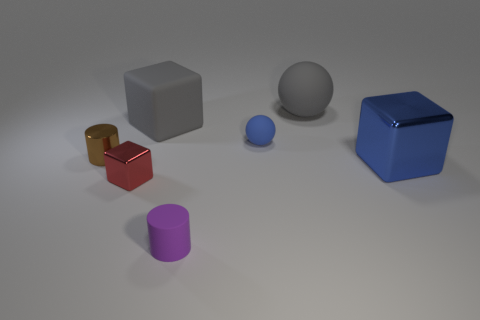How many objects are tiny red objects or rubber cylinders?
Give a very brief answer. 2. There is a red object that is in front of the gray matte thing to the right of the tiny matte thing in front of the red block; what is its size?
Offer a very short reply. Small. What number of spheres have the same color as the large matte cube?
Make the answer very short. 1. What number of red things are the same material as the gray cube?
Provide a short and direct response. 0. How many things are either purple cylinders or matte spheres that are in front of the gray block?
Your response must be concise. 2. What is the color of the sphere in front of the big object behind the gray matte thing on the left side of the big gray ball?
Your answer should be very brief. Blue. What is the size of the metallic cube on the left side of the small purple matte cylinder?
Keep it short and to the point. Small. What number of tiny things are spheres or shiny objects?
Ensure brevity in your answer.  3. The cube that is in front of the matte cube and left of the rubber cylinder is what color?
Your response must be concise. Red. Is there a large cyan metal object that has the same shape as the small red metallic object?
Provide a succinct answer. No. 